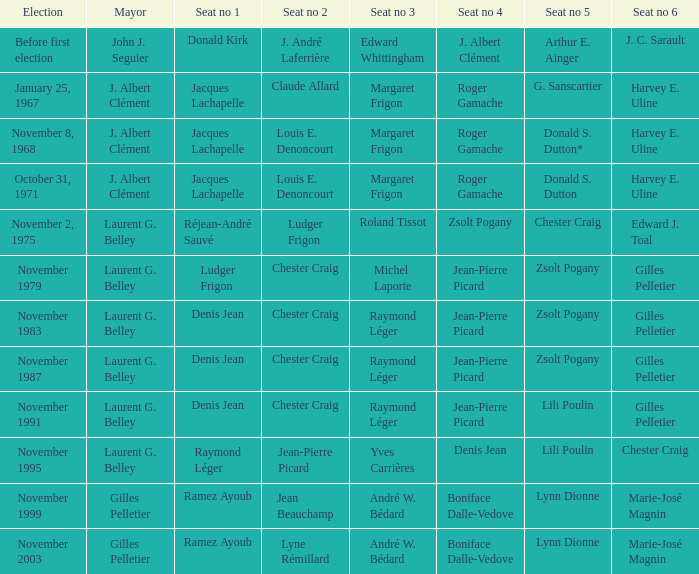Which election had seat no 1 filled by jacques lachapelle but seat no 5 was filled by g. sanscartier January 25, 1967. 